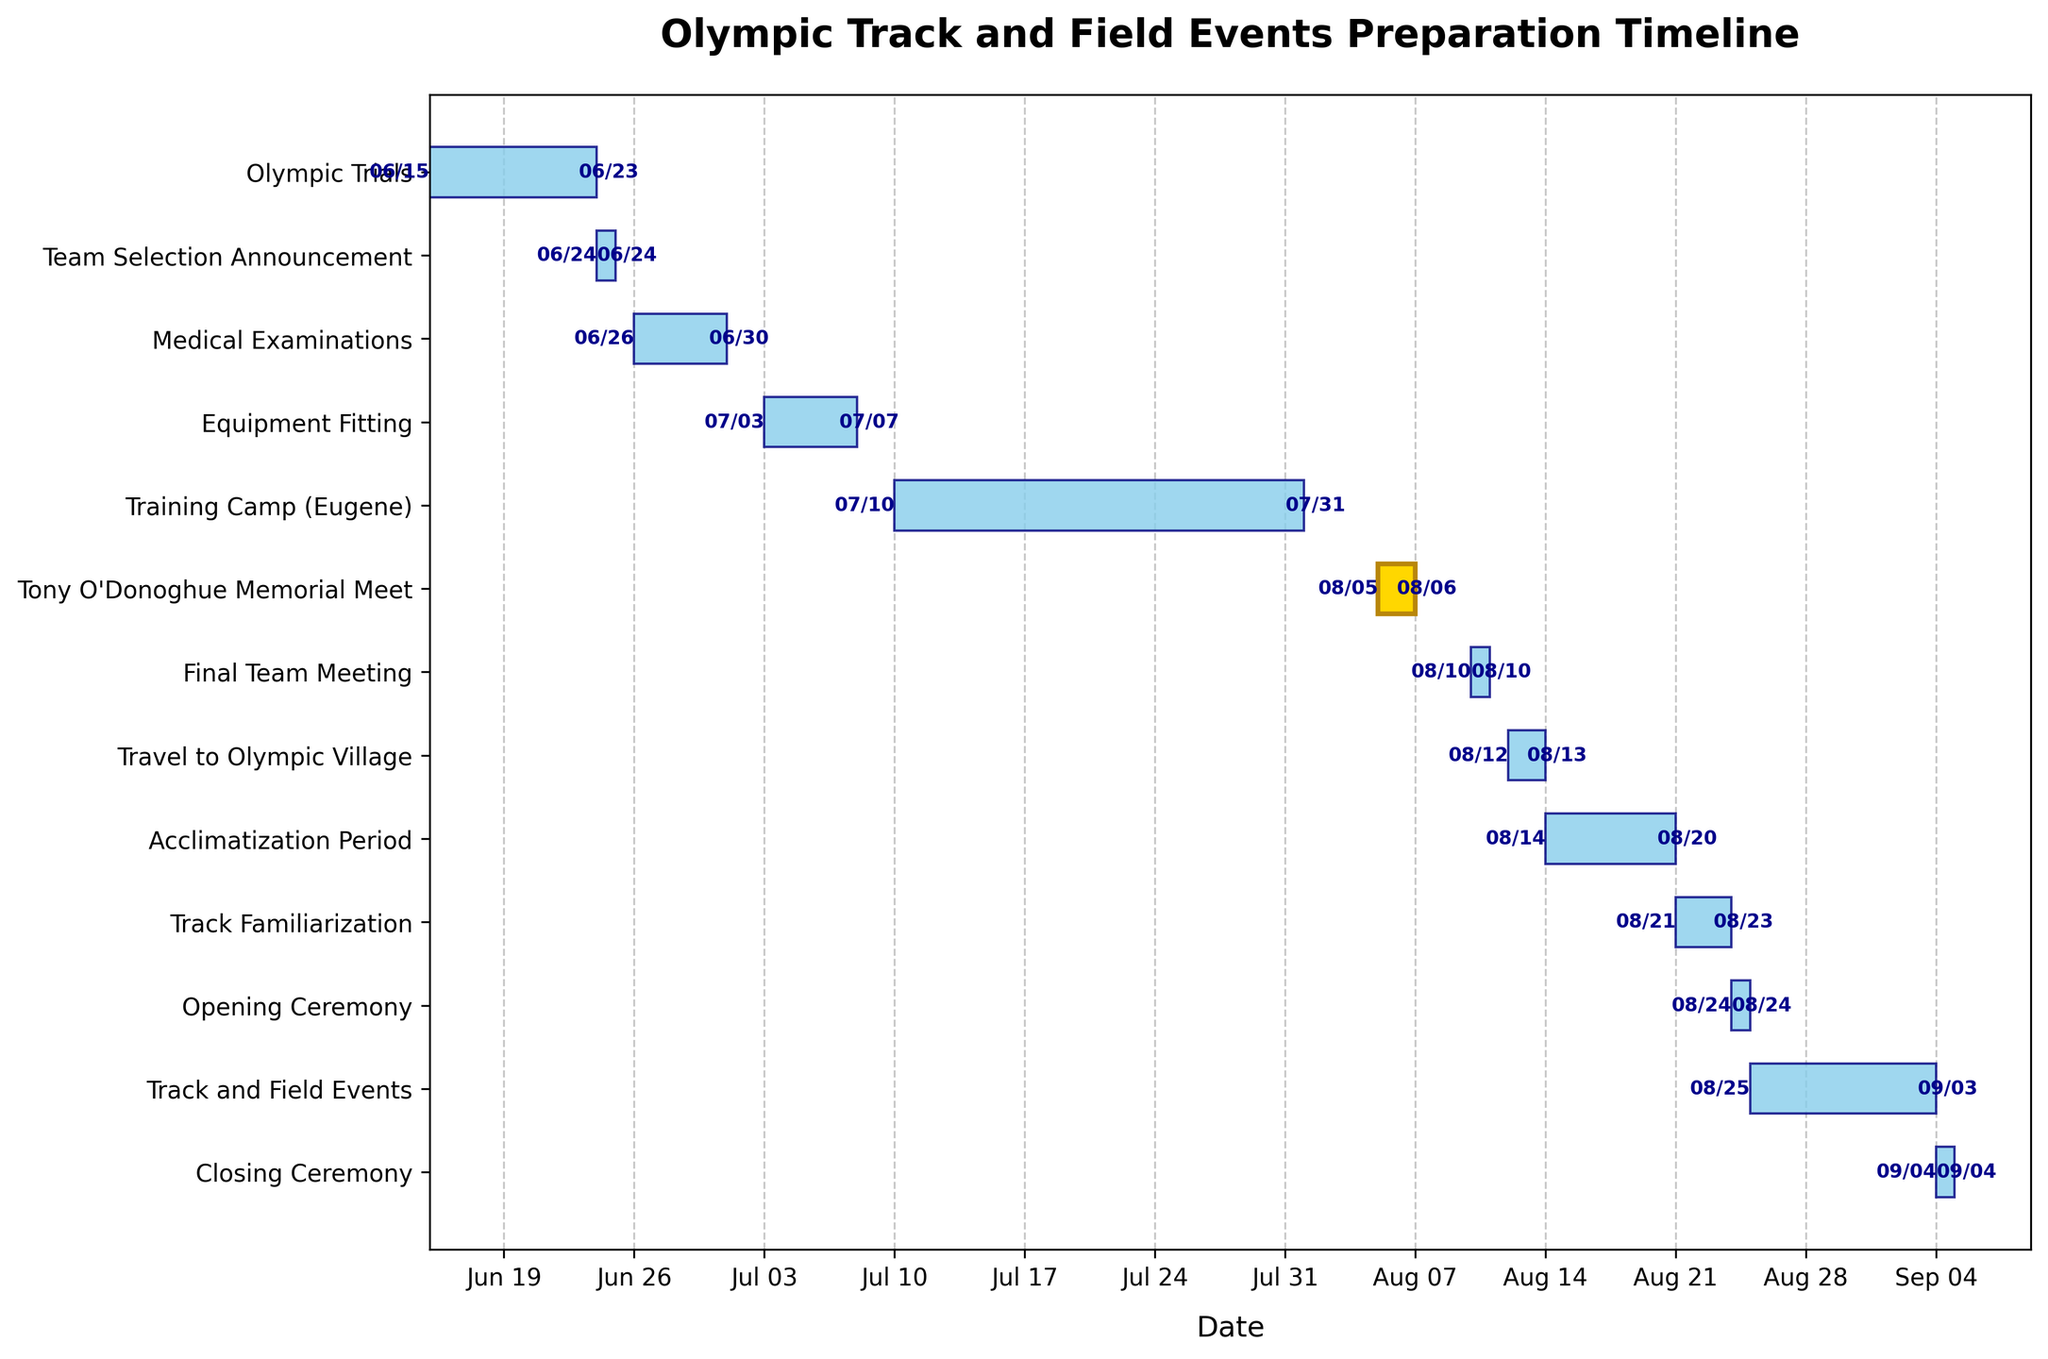what is the title of the chart? Look at the top of the chart where the title is typically placed. The title of the chart summarizes what the chart is about.
Answer: Olympic Track and Field Events Preparation Timeline How long is the Medical Examinations period? Identify the Medical Examinations task on the y-axis, then look at the length of the bar corresponding to this task. The period starts on 2023-06-26 and ends on 2023-06-30. Calculate the difference between the start and end dates (inclusive).
Answer: 5 days Which event has the shortest duration? Compare the lengths of the bars on the horizontal axis to determine which task has the shortest one.
Answer: Team Selection Announcement, Final Team Meeting, Opening Ceremony, Closing Ceremony (All 1 day) How much longer is the Training Camp (Eugene) compared to the Equipment Fitting period? Calculate the duration of both the Training Camp (2023-07-10 to 2023-07-31) and the Equipment Fitting (2023-07-03 to 2023-07-07). Subtract the duration of Equipment Fitting from the duration of Training Camp (22 days - 5 days).
Answer: 17 days Which task starts immediately after the Team Selection Announcement? Look for the task that follows the Team Selection Announcement on the timeline immediately, without any gap.
Answer: Medical Examinations How many events start in August 2023? Identify the events that have their start dates in August 2023 by examining the x-axis and the corresponding bars. Count these events.
Answer: 7 events When does the Track Familiarization end? Find the Track Familiarization task on the y-axis and look at the end date indicated on the corresponding bar.
Answer: 2023-08-23 Which event lasts the longest? Observe the lengths of all bars and identify the bar that stretches the furthest. This corresponds to the event with the longest duration.
Answer: Track and Field Events When does the Tony O'Donoghue Memorial Meet take place? Find the Tony O'Donoghue Memorial Meet on the y-axis and look at its start and end dates on the bar.
Answer: 2023-08-05 to 2023-08-06 What is the overall duration from the first event (Olympic Trials) to the last event (Closing Ceremony)? Note the start date of the first event (Olympic Trials on 2023-06-15) and the end date of the last event (Closing Ceremony on 2023-09-04). Subtract the start date from the end date (inclusive) to get the total duration.
Answer: 82 days 